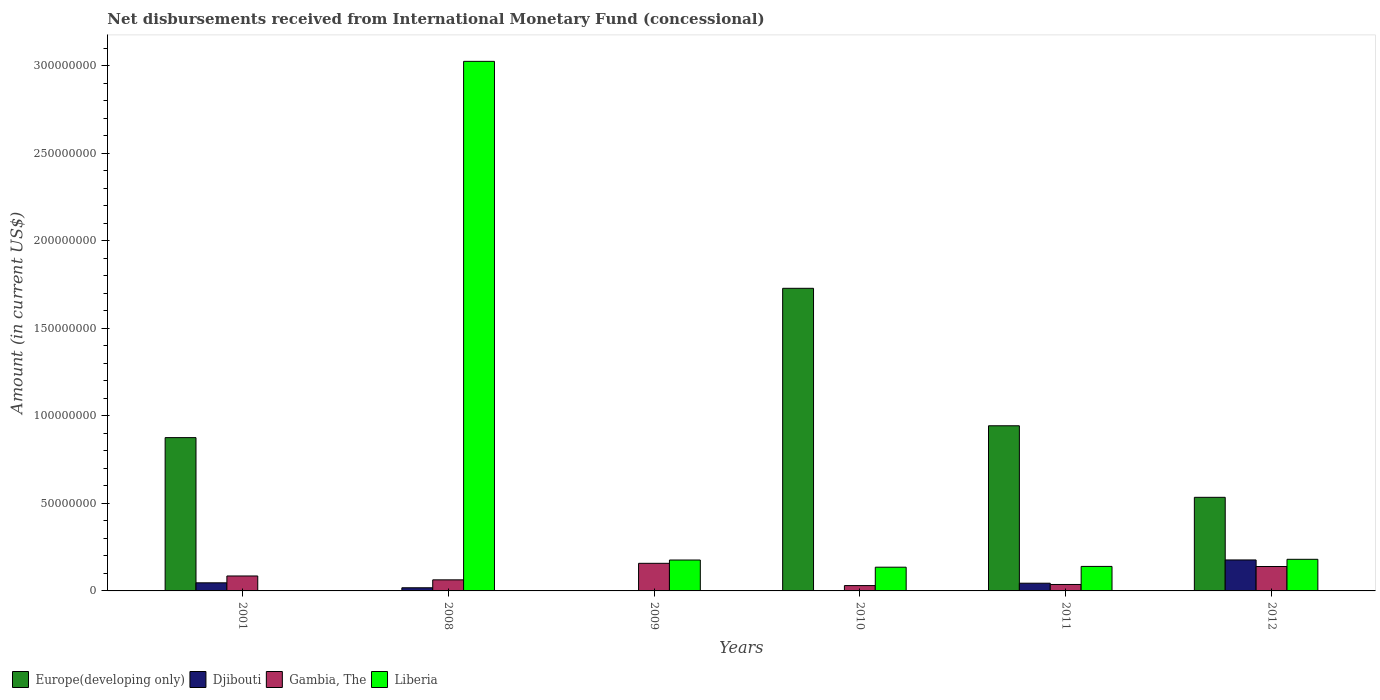How many groups of bars are there?
Offer a terse response. 6. Are the number of bars on each tick of the X-axis equal?
Your response must be concise. No. How many bars are there on the 4th tick from the left?
Provide a short and direct response. 3. In how many cases, is the number of bars for a given year not equal to the number of legend labels?
Your response must be concise. 4. What is the amount of disbursements received from International Monetary Fund in Liberia in 2012?
Your answer should be compact. 1.81e+07. Across all years, what is the maximum amount of disbursements received from International Monetary Fund in Liberia?
Offer a very short reply. 3.03e+08. Across all years, what is the minimum amount of disbursements received from International Monetary Fund in Djibouti?
Provide a short and direct response. 0. In which year was the amount of disbursements received from International Monetary Fund in Gambia, The maximum?
Offer a very short reply. 2009. What is the total amount of disbursements received from International Monetary Fund in Djibouti in the graph?
Keep it short and to the point. 2.85e+07. What is the difference between the amount of disbursements received from International Monetary Fund in Djibouti in 2008 and that in 2011?
Make the answer very short. -2.60e+06. What is the difference between the amount of disbursements received from International Monetary Fund in Gambia, The in 2008 and the amount of disbursements received from International Monetary Fund in Djibouti in 2009?
Your answer should be compact. 6.32e+06. What is the average amount of disbursements received from International Monetary Fund in Europe(developing only) per year?
Keep it short and to the point. 6.80e+07. In the year 2010, what is the difference between the amount of disbursements received from International Monetary Fund in Liberia and amount of disbursements received from International Monetary Fund in Gambia, The?
Make the answer very short. 1.05e+07. In how many years, is the amount of disbursements received from International Monetary Fund in Gambia, The greater than 210000000 US$?
Keep it short and to the point. 0. What is the ratio of the amount of disbursements received from International Monetary Fund in Djibouti in 2001 to that in 2012?
Provide a succinct answer. 0.26. Is the difference between the amount of disbursements received from International Monetary Fund in Liberia in 2010 and 2011 greater than the difference between the amount of disbursements received from International Monetary Fund in Gambia, The in 2010 and 2011?
Your answer should be compact. Yes. What is the difference between the highest and the second highest amount of disbursements received from International Monetary Fund in Gambia, The?
Make the answer very short. 1.82e+06. What is the difference between the highest and the lowest amount of disbursements received from International Monetary Fund in Gambia, The?
Provide a short and direct response. 1.27e+07. In how many years, is the amount of disbursements received from International Monetary Fund in Gambia, The greater than the average amount of disbursements received from International Monetary Fund in Gambia, The taken over all years?
Offer a very short reply. 2. Is the sum of the amount of disbursements received from International Monetary Fund in Liberia in 2009 and 2011 greater than the maximum amount of disbursements received from International Monetary Fund in Djibouti across all years?
Provide a short and direct response. Yes. Is it the case that in every year, the sum of the amount of disbursements received from International Monetary Fund in Liberia and amount of disbursements received from International Monetary Fund in Gambia, The is greater than the sum of amount of disbursements received from International Monetary Fund in Djibouti and amount of disbursements received from International Monetary Fund in Europe(developing only)?
Offer a very short reply. Yes. Are all the bars in the graph horizontal?
Offer a very short reply. No. How many years are there in the graph?
Provide a short and direct response. 6. Are the values on the major ticks of Y-axis written in scientific E-notation?
Your answer should be compact. No. How many legend labels are there?
Your answer should be very brief. 4. How are the legend labels stacked?
Provide a short and direct response. Horizontal. What is the title of the graph?
Your response must be concise. Net disbursements received from International Monetary Fund (concessional). Does "East Asia (developing only)" appear as one of the legend labels in the graph?
Make the answer very short. No. What is the Amount (in current US$) in Europe(developing only) in 2001?
Your response must be concise. 8.76e+07. What is the Amount (in current US$) in Djibouti in 2001?
Offer a very short reply. 4.63e+06. What is the Amount (in current US$) of Gambia, The in 2001?
Your response must be concise. 8.54e+06. What is the Amount (in current US$) in Djibouti in 2008?
Keep it short and to the point. 1.80e+06. What is the Amount (in current US$) in Gambia, The in 2008?
Give a very brief answer. 6.32e+06. What is the Amount (in current US$) in Liberia in 2008?
Offer a terse response. 3.03e+08. What is the Amount (in current US$) of Europe(developing only) in 2009?
Keep it short and to the point. 0. What is the Amount (in current US$) of Gambia, The in 2009?
Your answer should be very brief. 1.58e+07. What is the Amount (in current US$) of Liberia in 2009?
Provide a short and direct response. 1.76e+07. What is the Amount (in current US$) of Europe(developing only) in 2010?
Keep it short and to the point. 1.73e+08. What is the Amount (in current US$) of Gambia, The in 2010?
Your answer should be very brief. 3.04e+06. What is the Amount (in current US$) in Liberia in 2010?
Keep it short and to the point. 1.36e+07. What is the Amount (in current US$) in Europe(developing only) in 2011?
Your answer should be very brief. 9.43e+07. What is the Amount (in current US$) in Djibouti in 2011?
Provide a short and direct response. 4.40e+06. What is the Amount (in current US$) of Gambia, The in 2011?
Make the answer very short. 3.68e+06. What is the Amount (in current US$) in Liberia in 2011?
Ensure brevity in your answer.  1.40e+07. What is the Amount (in current US$) of Europe(developing only) in 2012?
Provide a short and direct response. 5.35e+07. What is the Amount (in current US$) of Djibouti in 2012?
Make the answer very short. 1.77e+07. What is the Amount (in current US$) of Gambia, The in 2012?
Provide a succinct answer. 1.39e+07. What is the Amount (in current US$) in Liberia in 2012?
Your response must be concise. 1.81e+07. Across all years, what is the maximum Amount (in current US$) of Europe(developing only)?
Ensure brevity in your answer.  1.73e+08. Across all years, what is the maximum Amount (in current US$) in Djibouti?
Give a very brief answer. 1.77e+07. Across all years, what is the maximum Amount (in current US$) of Gambia, The?
Offer a very short reply. 1.58e+07. Across all years, what is the maximum Amount (in current US$) of Liberia?
Your response must be concise. 3.03e+08. Across all years, what is the minimum Amount (in current US$) in Gambia, The?
Your answer should be compact. 3.04e+06. What is the total Amount (in current US$) of Europe(developing only) in the graph?
Your answer should be very brief. 4.08e+08. What is the total Amount (in current US$) of Djibouti in the graph?
Provide a short and direct response. 2.85e+07. What is the total Amount (in current US$) in Gambia, The in the graph?
Offer a terse response. 5.13e+07. What is the total Amount (in current US$) in Liberia in the graph?
Your answer should be compact. 3.66e+08. What is the difference between the Amount (in current US$) in Djibouti in 2001 and that in 2008?
Keep it short and to the point. 2.83e+06. What is the difference between the Amount (in current US$) in Gambia, The in 2001 and that in 2008?
Keep it short and to the point. 2.21e+06. What is the difference between the Amount (in current US$) of Gambia, The in 2001 and that in 2009?
Keep it short and to the point. -7.23e+06. What is the difference between the Amount (in current US$) in Europe(developing only) in 2001 and that in 2010?
Your response must be concise. -8.53e+07. What is the difference between the Amount (in current US$) in Gambia, The in 2001 and that in 2010?
Offer a very short reply. 5.49e+06. What is the difference between the Amount (in current US$) in Europe(developing only) in 2001 and that in 2011?
Your answer should be very brief. -6.76e+06. What is the difference between the Amount (in current US$) in Djibouti in 2001 and that in 2011?
Provide a succinct answer. 2.26e+05. What is the difference between the Amount (in current US$) of Gambia, The in 2001 and that in 2011?
Your answer should be very brief. 4.86e+06. What is the difference between the Amount (in current US$) of Europe(developing only) in 2001 and that in 2012?
Your answer should be very brief. 3.41e+07. What is the difference between the Amount (in current US$) of Djibouti in 2001 and that in 2012?
Keep it short and to the point. -1.31e+07. What is the difference between the Amount (in current US$) of Gambia, The in 2001 and that in 2012?
Your response must be concise. -5.41e+06. What is the difference between the Amount (in current US$) in Gambia, The in 2008 and that in 2009?
Ensure brevity in your answer.  -9.44e+06. What is the difference between the Amount (in current US$) in Liberia in 2008 and that in 2009?
Give a very brief answer. 2.85e+08. What is the difference between the Amount (in current US$) of Gambia, The in 2008 and that in 2010?
Provide a succinct answer. 3.28e+06. What is the difference between the Amount (in current US$) in Liberia in 2008 and that in 2010?
Offer a very short reply. 2.89e+08. What is the difference between the Amount (in current US$) of Djibouti in 2008 and that in 2011?
Ensure brevity in your answer.  -2.60e+06. What is the difference between the Amount (in current US$) in Gambia, The in 2008 and that in 2011?
Make the answer very short. 2.64e+06. What is the difference between the Amount (in current US$) in Liberia in 2008 and that in 2011?
Keep it short and to the point. 2.89e+08. What is the difference between the Amount (in current US$) in Djibouti in 2008 and that in 2012?
Give a very brief answer. -1.59e+07. What is the difference between the Amount (in current US$) in Gambia, The in 2008 and that in 2012?
Ensure brevity in your answer.  -7.62e+06. What is the difference between the Amount (in current US$) of Liberia in 2008 and that in 2012?
Make the answer very short. 2.84e+08. What is the difference between the Amount (in current US$) in Gambia, The in 2009 and that in 2010?
Your answer should be very brief. 1.27e+07. What is the difference between the Amount (in current US$) of Liberia in 2009 and that in 2010?
Offer a terse response. 4.10e+06. What is the difference between the Amount (in current US$) of Gambia, The in 2009 and that in 2011?
Offer a very short reply. 1.21e+07. What is the difference between the Amount (in current US$) in Liberia in 2009 and that in 2011?
Your answer should be compact. 3.64e+06. What is the difference between the Amount (in current US$) in Gambia, The in 2009 and that in 2012?
Your response must be concise. 1.82e+06. What is the difference between the Amount (in current US$) of Liberia in 2009 and that in 2012?
Provide a succinct answer. -4.13e+05. What is the difference between the Amount (in current US$) in Europe(developing only) in 2010 and that in 2011?
Offer a very short reply. 7.85e+07. What is the difference between the Amount (in current US$) of Gambia, The in 2010 and that in 2011?
Provide a succinct answer. -6.35e+05. What is the difference between the Amount (in current US$) of Liberia in 2010 and that in 2011?
Your response must be concise. -4.52e+05. What is the difference between the Amount (in current US$) of Europe(developing only) in 2010 and that in 2012?
Provide a short and direct response. 1.19e+08. What is the difference between the Amount (in current US$) of Gambia, The in 2010 and that in 2012?
Provide a succinct answer. -1.09e+07. What is the difference between the Amount (in current US$) of Liberia in 2010 and that in 2012?
Offer a very short reply. -4.51e+06. What is the difference between the Amount (in current US$) in Europe(developing only) in 2011 and that in 2012?
Your answer should be very brief. 4.09e+07. What is the difference between the Amount (in current US$) of Djibouti in 2011 and that in 2012?
Offer a terse response. -1.33e+07. What is the difference between the Amount (in current US$) in Gambia, The in 2011 and that in 2012?
Provide a short and direct response. -1.03e+07. What is the difference between the Amount (in current US$) of Liberia in 2011 and that in 2012?
Your answer should be compact. -4.06e+06. What is the difference between the Amount (in current US$) in Europe(developing only) in 2001 and the Amount (in current US$) in Djibouti in 2008?
Your answer should be very brief. 8.58e+07. What is the difference between the Amount (in current US$) in Europe(developing only) in 2001 and the Amount (in current US$) in Gambia, The in 2008?
Offer a very short reply. 8.13e+07. What is the difference between the Amount (in current US$) of Europe(developing only) in 2001 and the Amount (in current US$) of Liberia in 2008?
Your answer should be compact. -2.15e+08. What is the difference between the Amount (in current US$) of Djibouti in 2001 and the Amount (in current US$) of Gambia, The in 2008?
Offer a very short reply. -1.70e+06. What is the difference between the Amount (in current US$) of Djibouti in 2001 and the Amount (in current US$) of Liberia in 2008?
Ensure brevity in your answer.  -2.98e+08. What is the difference between the Amount (in current US$) in Gambia, The in 2001 and the Amount (in current US$) in Liberia in 2008?
Your answer should be very brief. -2.94e+08. What is the difference between the Amount (in current US$) in Europe(developing only) in 2001 and the Amount (in current US$) in Gambia, The in 2009?
Your answer should be very brief. 7.18e+07. What is the difference between the Amount (in current US$) in Europe(developing only) in 2001 and the Amount (in current US$) in Liberia in 2009?
Ensure brevity in your answer.  6.99e+07. What is the difference between the Amount (in current US$) in Djibouti in 2001 and the Amount (in current US$) in Gambia, The in 2009?
Give a very brief answer. -1.11e+07. What is the difference between the Amount (in current US$) of Djibouti in 2001 and the Amount (in current US$) of Liberia in 2009?
Your answer should be compact. -1.30e+07. What is the difference between the Amount (in current US$) of Gambia, The in 2001 and the Amount (in current US$) of Liberia in 2009?
Make the answer very short. -9.11e+06. What is the difference between the Amount (in current US$) in Europe(developing only) in 2001 and the Amount (in current US$) in Gambia, The in 2010?
Make the answer very short. 8.45e+07. What is the difference between the Amount (in current US$) of Europe(developing only) in 2001 and the Amount (in current US$) of Liberia in 2010?
Give a very brief answer. 7.40e+07. What is the difference between the Amount (in current US$) in Djibouti in 2001 and the Amount (in current US$) in Gambia, The in 2010?
Provide a short and direct response. 1.58e+06. What is the difference between the Amount (in current US$) in Djibouti in 2001 and the Amount (in current US$) in Liberia in 2010?
Keep it short and to the point. -8.92e+06. What is the difference between the Amount (in current US$) in Gambia, The in 2001 and the Amount (in current US$) in Liberia in 2010?
Ensure brevity in your answer.  -5.02e+06. What is the difference between the Amount (in current US$) of Europe(developing only) in 2001 and the Amount (in current US$) of Djibouti in 2011?
Offer a very short reply. 8.32e+07. What is the difference between the Amount (in current US$) of Europe(developing only) in 2001 and the Amount (in current US$) of Gambia, The in 2011?
Give a very brief answer. 8.39e+07. What is the difference between the Amount (in current US$) in Europe(developing only) in 2001 and the Amount (in current US$) in Liberia in 2011?
Ensure brevity in your answer.  7.36e+07. What is the difference between the Amount (in current US$) of Djibouti in 2001 and the Amount (in current US$) of Gambia, The in 2011?
Make the answer very short. 9.49e+05. What is the difference between the Amount (in current US$) in Djibouti in 2001 and the Amount (in current US$) in Liberia in 2011?
Your answer should be very brief. -9.37e+06. What is the difference between the Amount (in current US$) in Gambia, The in 2001 and the Amount (in current US$) in Liberia in 2011?
Your answer should be very brief. -5.47e+06. What is the difference between the Amount (in current US$) of Europe(developing only) in 2001 and the Amount (in current US$) of Djibouti in 2012?
Provide a short and direct response. 6.99e+07. What is the difference between the Amount (in current US$) in Europe(developing only) in 2001 and the Amount (in current US$) in Gambia, The in 2012?
Keep it short and to the point. 7.36e+07. What is the difference between the Amount (in current US$) of Europe(developing only) in 2001 and the Amount (in current US$) of Liberia in 2012?
Provide a succinct answer. 6.95e+07. What is the difference between the Amount (in current US$) of Djibouti in 2001 and the Amount (in current US$) of Gambia, The in 2012?
Keep it short and to the point. -9.32e+06. What is the difference between the Amount (in current US$) of Djibouti in 2001 and the Amount (in current US$) of Liberia in 2012?
Provide a short and direct response. -1.34e+07. What is the difference between the Amount (in current US$) of Gambia, The in 2001 and the Amount (in current US$) of Liberia in 2012?
Provide a succinct answer. -9.52e+06. What is the difference between the Amount (in current US$) in Djibouti in 2008 and the Amount (in current US$) in Gambia, The in 2009?
Offer a terse response. -1.40e+07. What is the difference between the Amount (in current US$) in Djibouti in 2008 and the Amount (in current US$) in Liberia in 2009?
Provide a short and direct response. -1.58e+07. What is the difference between the Amount (in current US$) in Gambia, The in 2008 and the Amount (in current US$) in Liberia in 2009?
Give a very brief answer. -1.13e+07. What is the difference between the Amount (in current US$) of Djibouti in 2008 and the Amount (in current US$) of Gambia, The in 2010?
Provide a short and direct response. -1.24e+06. What is the difference between the Amount (in current US$) in Djibouti in 2008 and the Amount (in current US$) in Liberia in 2010?
Provide a short and direct response. -1.18e+07. What is the difference between the Amount (in current US$) of Gambia, The in 2008 and the Amount (in current US$) of Liberia in 2010?
Your answer should be very brief. -7.23e+06. What is the difference between the Amount (in current US$) in Djibouti in 2008 and the Amount (in current US$) in Gambia, The in 2011?
Keep it short and to the point. -1.88e+06. What is the difference between the Amount (in current US$) in Djibouti in 2008 and the Amount (in current US$) in Liberia in 2011?
Give a very brief answer. -1.22e+07. What is the difference between the Amount (in current US$) of Gambia, The in 2008 and the Amount (in current US$) of Liberia in 2011?
Keep it short and to the point. -7.68e+06. What is the difference between the Amount (in current US$) of Djibouti in 2008 and the Amount (in current US$) of Gambia, The in 2012?
Provide a succinct answer. -1.21e+07. What is the difference between the Amount (in current US$) of Djibouti in 2008 and the Amount (in current US$) of Liberia in 2012?
Make the answer very short. -1.63e+07. What is the difference between the Amount (in current US$) in Gambia, The in 2008 and the Amount (in current US$) in Liberia in 2012?
Provide a short and direct response. -1.17e+07. What is the difference between the Amount (in current US$) of Gambia, The in 2009 and the Amount (in current US$) of Liberia in 2010?
Keep it short and to the point. 2.21e+06. What is the difference between the Amount (in current US$) in Gambia, The in 2009 and the Amount (in current US$) in Liberia in 2011?
Your response must be concise. 1.76e+06. What is the difference between the Amount (in current US$) in Gambia, The in 2009 and the Amount (in current US$) in Liberia in 2012?
Provide a short and direct response. -2.30e+06. What is the difference between the Amount (in current US$) in Europe(developing only) in 2010 and the Amount (in current US$) in Djibouti in 2011?
Provide a succinct answer. 1.68e+08. What is the difference between the Amount (in current US$) of Europe(developing only) in 2010 and the Amount (in current US$) of Gambia, The in 2011?
Make the answer very short. 1.69e+08. What is the difference between the Amount (in current US$) of Europe(developing only) in 2010 and the Amount (in current US$) of Liberia in 2011?
Provide a succinct answer. 1.59e+08. What is the difference between the Amount (in current US$) of Gambia, The in 2010 and the Amount (in current US$) of Liberia in 2011?
Give a very brief answer. -1.10e+07. What is the difference between the Amount (in current US$) of Europe(developing only) in 2010 and the Amount (in current US$) of Djibouti in 2012?
Keep it short and to the point. 1.55e+08. What is the difference between the Amount (in current US$) of Europe(developing only) in 2010 and the Amount (in current US$) of Gambia, The in 2012?
Offer a very short reply. 1.59e+08. What is the difference between the Amount (in current US$) of Europe(developing only) in 2010 and the Amount (in current US$) of Liberia in 2012?
Offer a very short reply. 1.55e+08. What is the difference between the Amount (in current US$) in Gambia, The in 2010 and the Amount (in current US$) in Liberia in 2012?
Make the answer very short. -1.50e+07. What is the difference between the Amount (in current US$) in Europe(developing only) in 2011 and the Amount (in current US$) in Djibouti in 2012?
Make the answer very short. 7.66e+07. What is the difference between the Amount (in current US$) in Europe(developing only) in 2011 and the Amount (in current US$) in Gambia, The in 2012?
Keep it short and to the point. 8.04e+07. What is the difference between the Amount (in current US$) in Europe(developing only) in 2011 and the Amount (in current US$) in Liberia in 2012?
Provide a succinct answer. 7.63e+07. What is the difference between the Amount (in current US$) of Djibouti in 2011 and the Amount (in current US$) of Gambia, The in 2012?
Your answer should be compact. -9.54e+06. What is the difference between the Amount (in current US$) of Djibouti in 2011 and the Amount (in current US$) of Liberia in 2012?
Offer a very short reply. -1.37e+07. What is the difference between the Amount (in current US$) in Gambia, The in 2011 and the Amount (in current US$) in Liberia in 2012?
Keep it short and to the point. -1.44e+07. What is the average Amount (in current US$) of Europe(developing only) per year?
Your answer should be compact. 6.80e+07. What is the average Amount (in current US$) of Djibouti per year?
Give a very brief answer. 4.75e+06. What is the average Amount (in current US$) of Gambia, The per year?
Provide a succinct answer. 8.55e+06. What is the average Amount (in current US$) of Liberia per year?
Keep it short and to the point. 6.10e+07. In the year 2001, what is the difference between the Amount (in current US$) of Europe(developing only) and Amount (in current US$) of Djibouti?
Make the answer very short. 8.29e+07. In the year 2001, what is the difference between the Amount (in current US$) of Europe(developing only) and Amount (in current US$) of Gambia, The?
Your response must be concise. 7.90e+07. In the year 2001, what is the difference between the Amount (in current US$) of Djibouti and Amount (in current US$) of Gambia, The?
Provide a succinct answer. -3.91e+06. In the year 2008, what is the difference between the Amount (in current US$) in Djibouti and Amount (in current US$) in Gambia, The?
Your response must be concise. -4.52e+06. In the year 2008, what is the difference between the Amount (in current US$) in Djibouti and Amount (in current US$) in Liberia?
Offer a terse response. -3.01e+08. In the year 2008, what is the difference between the Amount (in current US$) in Gambia, The and Amount (in current US$) in Liberia?
Make the answer very short. -2.96e+08. In the year 2009, what is the difference between the Amount (in current US$) in Gambia, The and Amount (in current US$) in Liberia?
Make the answer very short. -1.88e+06. In the year 2010, what is the difference between the Amount (in current US$) in Europe(developing only) and Amount (in current US$) in Gambia, The?
Give a very brief answer. 1.70e+08. In the year 2010, what is the difference between the Amount (in current US$) of Europe(developing only) and Amount (in current US$) of Liberia?
Ensure brevity in your answer.  1.59e+08. In the year 2010, what is the difference between the Amount (in current US$) of Gambia, The and Amount (in current US$) of Liberia?
Offer a terse response. -1.05e+07. In the year 2011, what is the difference between the Amount (in current US$) of Europe(developing only) and Amount (in current US$) of Djibouti?
Offer a terse response. 8.99e+07. In the year 2011, what is the difference between the Amount (in current US$) of Europe(developing only) and Amount (in current US$) of Gambia, The?
Offer a very short reply. 9.07e+07. In the year 2011, what is the difference between the Amount (in current US$) of Europe(developing only) and Amount (in current US$) of Liberia?
Your answer should be very brief. 8.03e+07. In the year 2011, what is the difference between the Amount (in current US$) of Djibouti and Amount (in current US$) of Gambia, The?
Offer a very short reply. 7.23e+05. In the year 2011, what is the difference between the Amount (in current US$) of Djibouti and Amount (in current US$) of Liberia?
Your response must be concise. -9.60e+06. In the year 2011, what is the difference between the Amount (in current US$) in Gambia, The and Amount (in current US$) in Liberia?
Keep it short and to the point. -1.03e+07. In the year 2012, what is the difference between the Amount (in current US$) of Europe(developing only) and Amount (in current US$) of Djibouti?
Keep it short and to the point. 3.58e+07. In the year 2012, what is the difference between the Amount (in current US$) in Europe(developing only) and Amount (in current US$) in Gambia, The?
Your answer should be very brief. 3.95e+07. In the year 2012, what is the difference between the Amount (in current US$) in Europe(developing only) and Amount (in current US$) in Liberia?
Your answer should be very brief. 3.54e+07. In the year 2012, what is the difference between the Amount (in current US$) of Djibouti and Amount (in current US$) of Gambia, The?
Provide a short and direct response. 3.75e+06. In the year 2012, what is the difference between the Amount (in current US$) of Djibouti and Amount (in current US$) of Liberia?
Provide a succinct answer. -3.66e+05. In the year 2012, what is the difference between the Amount (in current US$) of Gambia, The and Amount (in current US$) of Liberia?
Provide a short and direct response. -4.11e+06. What is the ratio of the Amount (in current US$) of Djibouti in 2001 to that in 2008?
Give a very brief answer. 2.57. What is the ratio of the Amount (in current US$) in Gambia, The in 2001 to that in 2008?
Make the answer very short. 1.35. What is the ratio of the Amount (in current US$) of Gambia, The in 2001 to that in 2009?
Provide a short and direct response. 0.54. What is the ratio of the Amount (in current US$) in Europe(developing only) in 2001 to that in 2010?
Your answer should be compact. 0.51. What is the ratio of the Amount (in current US$) in Gambia, The in 2001 to that in 2010?
Offer a very short reply. 2.8. What is the ratio of the Amount (in current US$) in Europe(developing only) in 2001 to that in 2011?
Offer a very short reply. 0.93. What is the ratio of the Amount (in current US$) of Djibouti in 2001 to that in 2011?
Provide a short and direct response. 1.05. What is the ratio of the Amount (in current US$) of Gambia, The in 2001 to that in 2011?
Provide a short and direct response. 2.32. What is the ratio of the Amount (in current US$) of Europe(developing only) in 2001 to that in 2012?
Make the answer very short. 1.64. What is the ratio of the Amount (in current US$) of Djibouti in 2001 to that in 2012?
Give a very brief answer. 0.26. What is the ratio of the Amount (in current US$) of Gambia, The in 2001 to that in 2012?
Provide a short and direct response. 0.61. What is the ratio of the Amount (in current US$) of Gambia, The in 2008 to that in 2009?
Your response must be concise. 0.4. What is the ratio of the Amount (in current US$) in Liberia in 2008 to that in 2009?
Offer a terse response. 17.14. What is the ratio of the Amount (in current US$) of Gambia, The in 2008 to that in 2010?
Ensure brevity in your answer.  2.08. What is the ratio of the Amount (in current US$) of Liberia in 2008 to that in 2010?
Provide a short and direct response. 22.33. What is the ratio of the Amount (in current US$) in Djibouti in 2008 to that in 2011?
Your answer should be very brief. 0.41. What is the ratio of the Amount (in current US$) in Gambia, The in 2008 to that in 2011?
Provide a succinct answer. 1.72. What is the ratio of the Amount (in current US$) of Liberia in 2008 to that in 2011?
Your response must be concise. 21.6. What is the ratio of the Amount (in current US$) of Djibouti in 2008 to that in 2012?
Ensure brevity in your answer.  0.1. What is the ratio of the Amount (in current US$) in Gambia, The in 2008 to that in 2012?
Keep it short and to the point. 0.45. What is the ratio of the Amount (in current US$) of Liberia in 2008 to that in 2012?
Ensure brevity in your answer.  16.75. What is the ratio of the Amount (in current US$) of Gambia, The in 2009 to that in 2010?
Provide a succinct answer. 5.18. What is the ratio of the Amount (in current US$) in Liberia in 2009 to that in 2010?
Ensure brevity in your answer.  1.3. What is the ratio of the Amount (in current US$) of Gambia, The in 2009 to that in 2011?
Your response must be concise. 4.28. What is the ratio of the Amount (in current US$) of Liberia in 2009 to that in 2011?
Make the answer very short. 1.26. What is the ratio of the Amount (in current US$) in Gambia, The in 2009 to that in 2012?
Offer a terse response. 1.13. What is the ratio of the Amount (in current US$) of Liberia in 2009 to that in 2012?
Ensure brevity in your answer.  0.98. What is the ratio of the Amount (in current US$) in Europe(developing only) in 2010 to that in 2011?
Make the answer very short. 1.83. What is the ratio of the Amount (in current US$) of Gambia, The in 2010 to that in 2011?
Offer a terse response. 0.83. What is the ratio of the Amount (in current US$) of Europe(developing only) in 2010 to that in 2012?
Your response must be concise. 3.23. What is the ratio of the Amount (in current US$) of Gambia, The in 2010 to that in 2012?
Provide a short and direct response. 0.22. What is the ratio of the Amount (in current US$) in Liberia in 2010 to that in 2012?
Your answer should be compact. 0.75. What is the ratio of the Amount (in current US$) in Europe(developing only) in 2011 to that in 2012?
Your answer should be compact. 1.76. What is the ratio of the Amount (in current US$) of Djibouti in 2011 to that in 2012?
Offer a terse response. 0.25. What is the ratio of the Amount (in current US$) of Gambia, The in 2011 to that in 2012?
Provide a succinct answer. 0.26. What is the ratio of the Amount (in current US$) of Liberia in 2011 to that in 2012?
Provide a short and direct response. 0.78. What is the difference between the highest and the second highest Amount (in current US$) of Europe(developing only)?
Your answer should be compact. 7.85e+07. What is the difference between the highest and the second highest Amount (in current US$) in Djibouti?
Give a very brief answer. 1.31e+07. What is the difference between the highest and the second highest Amount (in current US$) in Gambia, The?
Offer a very short reply. 1.82e+06. What is the difference between the highest and the second highest Amount (in current US$) in Liberia?
Provide a short and direct response. 2.84e+08. What is the difference between the highest and the lowest Amount (in current US$) in Europe(developing only)?
Your answer should be very brief. 1.73e+08. What is the difference between the highest and the lowest Amount (in current US$) in Djibouti?
Offer a very short reply. 1.77e+07. What is the difference between the highest and the lowest Amount (in current US$) in Gambia, The?
Make the answer very short. 1.27e+07. What is the difference between the highest and the lowest Amount (in current US$) of Liberia?
Ensure brevity in your answer.  3.03e+08. 